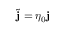<formula> <loc_0><loc_0><loc_500><loc_500>\tilde { j } = \eta _ { 0 } j</formula> 